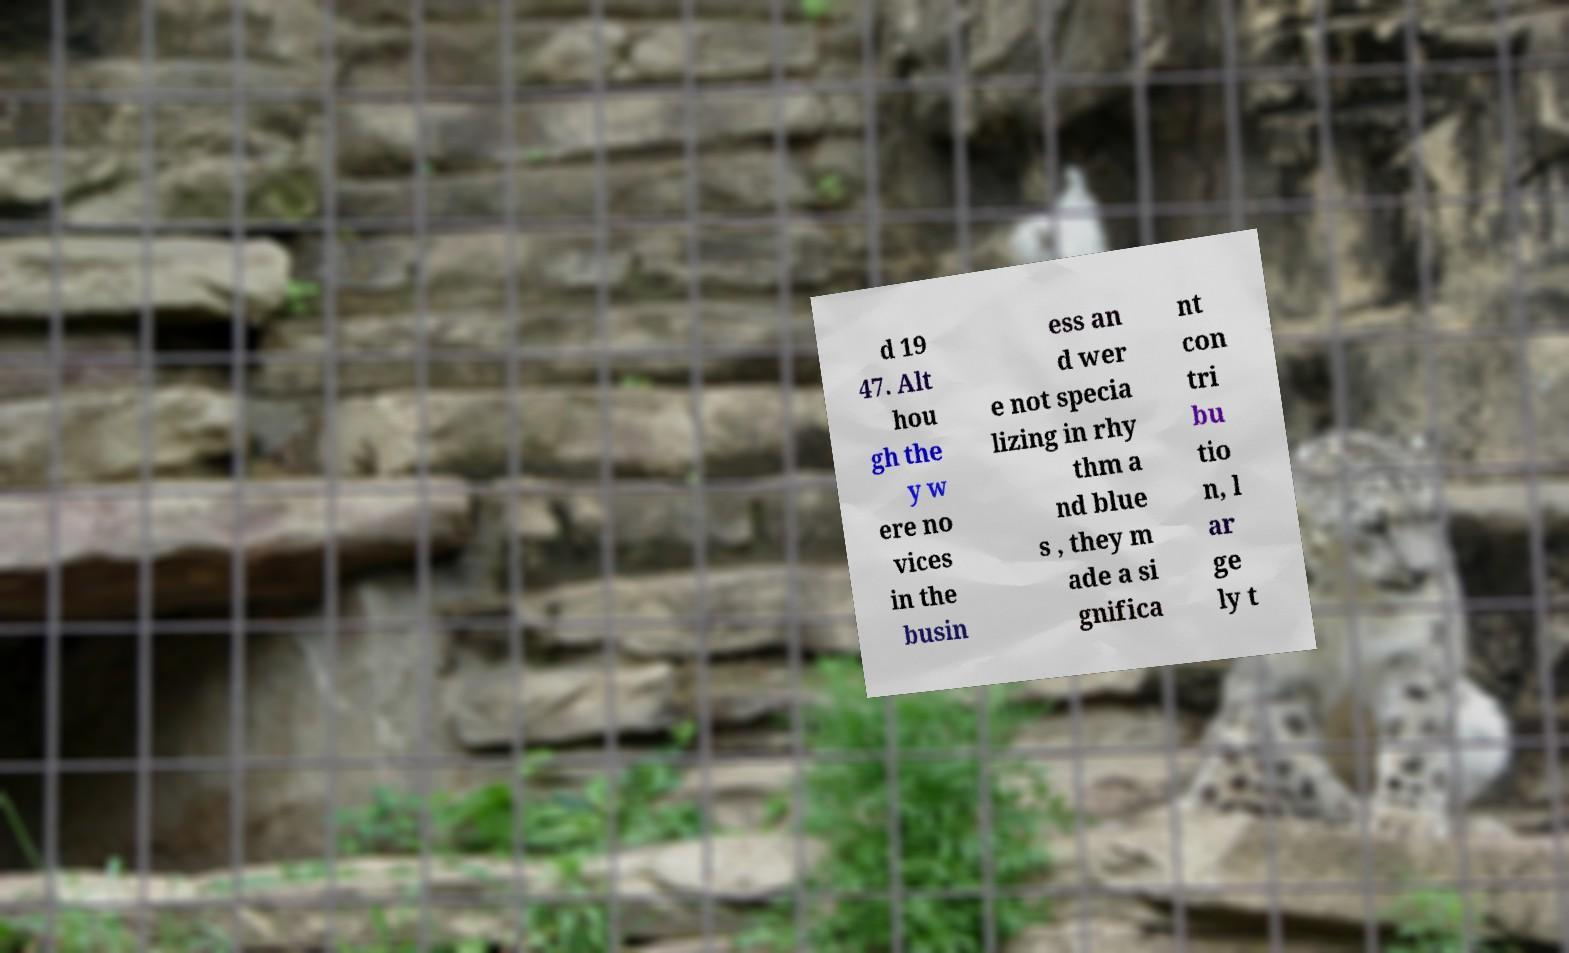Can you accurately transcribe the text from the provided image for me? d 19 47. Alt hou gh the y w ere no vices in the busin ess an d wer e not specia lizing in rhy thm a nd blue s , they m ade a si gnifica nt con tri bu tio n, l ar ge ly t 